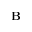<formula> <loc_0><loc_0><loc_500><loc_500>B</formula> 